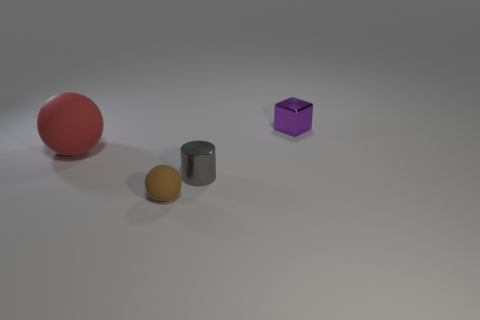How many gray things have the same size as the purple shiny block?
Offer a very short reply. 1. How many things are either tiny objects that are on the right side of the small gray object or large matte objects?
Ensure brevity in your answer.  2. Are there fewer large cyan metallic spheres than small matte balls?
Provide a short and direct response. Yes. The gray object that is the same material as the block is what shape?
Your answer should be compact. Cylinder. Are there any tiny purple metal cubes in front of the small matte thing?
Offer a terse response. No. Are there fewer small rubber balls right of the purple metallic object than tiny green balls?
Ensure brevity in your answer.  No. What is the small purple object made of?
Offer a very short reply. Metal. What is the color of the metallic cube?
Provide a short and direct response. Purple. The object that is behind the tiny gray cylinder and on the right side of the red rubber thing is what color?
Provide a succinct answer. Purple. Do the small purple cube and the sphere in front of the large rubber sphere have the same material?
Offer a terse response. No. 